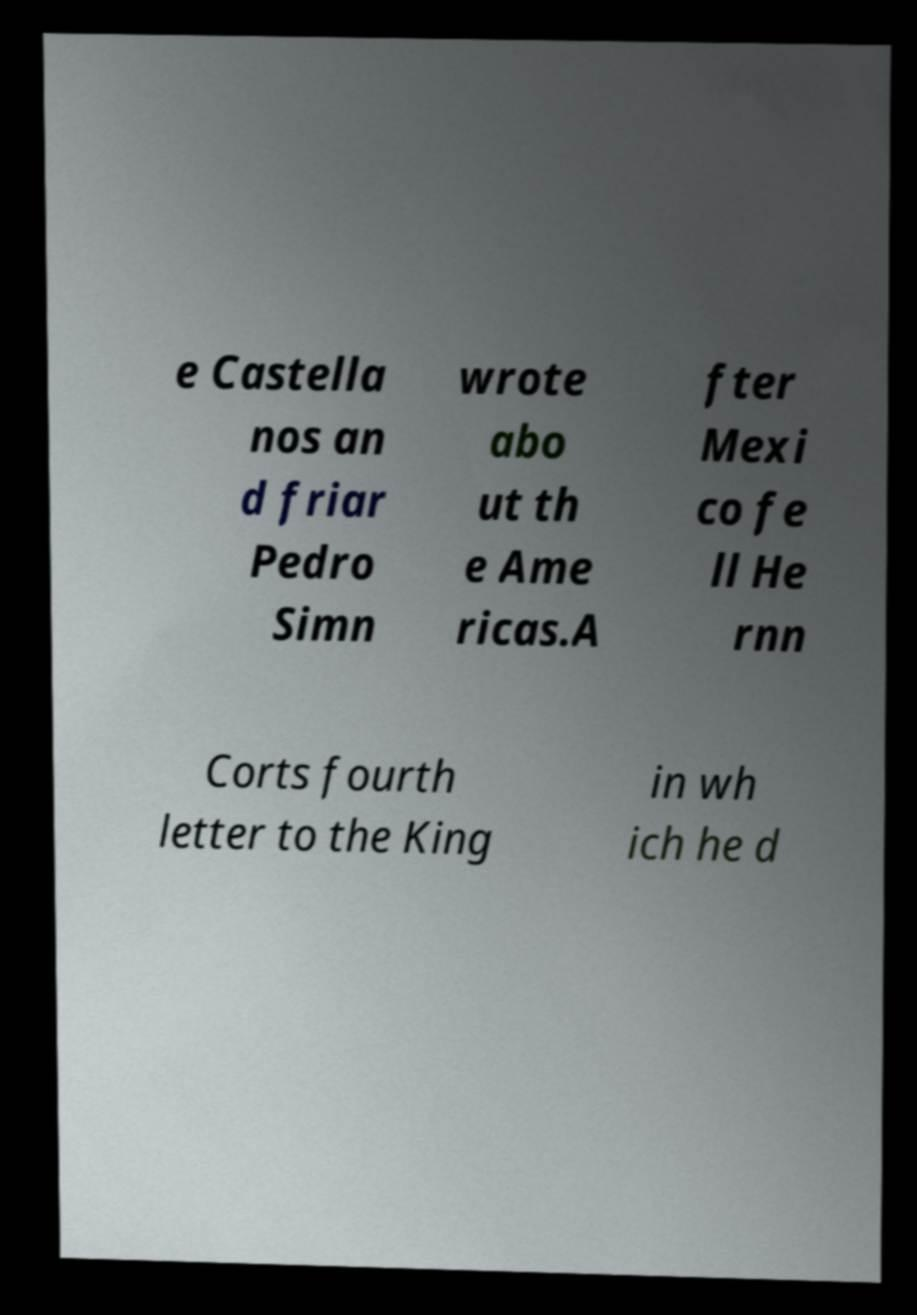For documentation purposes, I need the text within this image transcribed. Could you provide that? e Castella nos an d friar Pedro Simn wrote abo ut th e Ame ricas.A fter Mexi co fe ll He rnn Corts fourth letter to the King in wh ich he d 